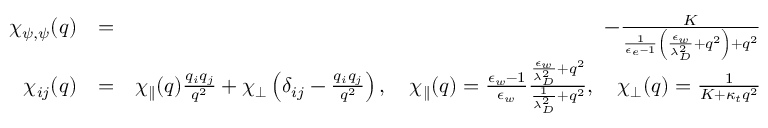Convert formula to latex. <formula><loc_0><loc_0><loc_500><loc_500>\begin{array} { r l r } { \chi _ { \psi , \psi } ( q ) } & { = } & { - \frac { K } { \frac { 1 } { \epsilon _ { e } - 1 } \left ( \frac { \epsilon _ { w } } { \lambda _ { D } ^ { 2 } } + q ^ { 2 } \right ) + q ^ { 2 } } } \\ { \chi _ { i j } ( q ) } & { = } & { \chi _ { \| } ( q ) \frac { q _ { i } q _ { j } } { q ^ { 2 } } + \chi _ { \perp } \left ( \delta _ { i j } - \frac { q _ { i } q _ { j } } { q ^ { 2 } } \right ) , \quad \chi _ { \| } ( q ) = \frac { \epsilon _ { w } - 1 } { \epsilon _ { w } } \frac { \frac { \epsilon _ { w } } { \lambda _ { D } ^ { 2 } } + q ^ { 2 } } { \frac { 1 } { \lambda _ { D } ^ { 2 } } + q ^ { 2 } } , \quad \chi _ { \perp } ( q ) = \frac { 1 } { K + \kappa _ { t } q ^ { 2 } } } \end{array}</formula> 